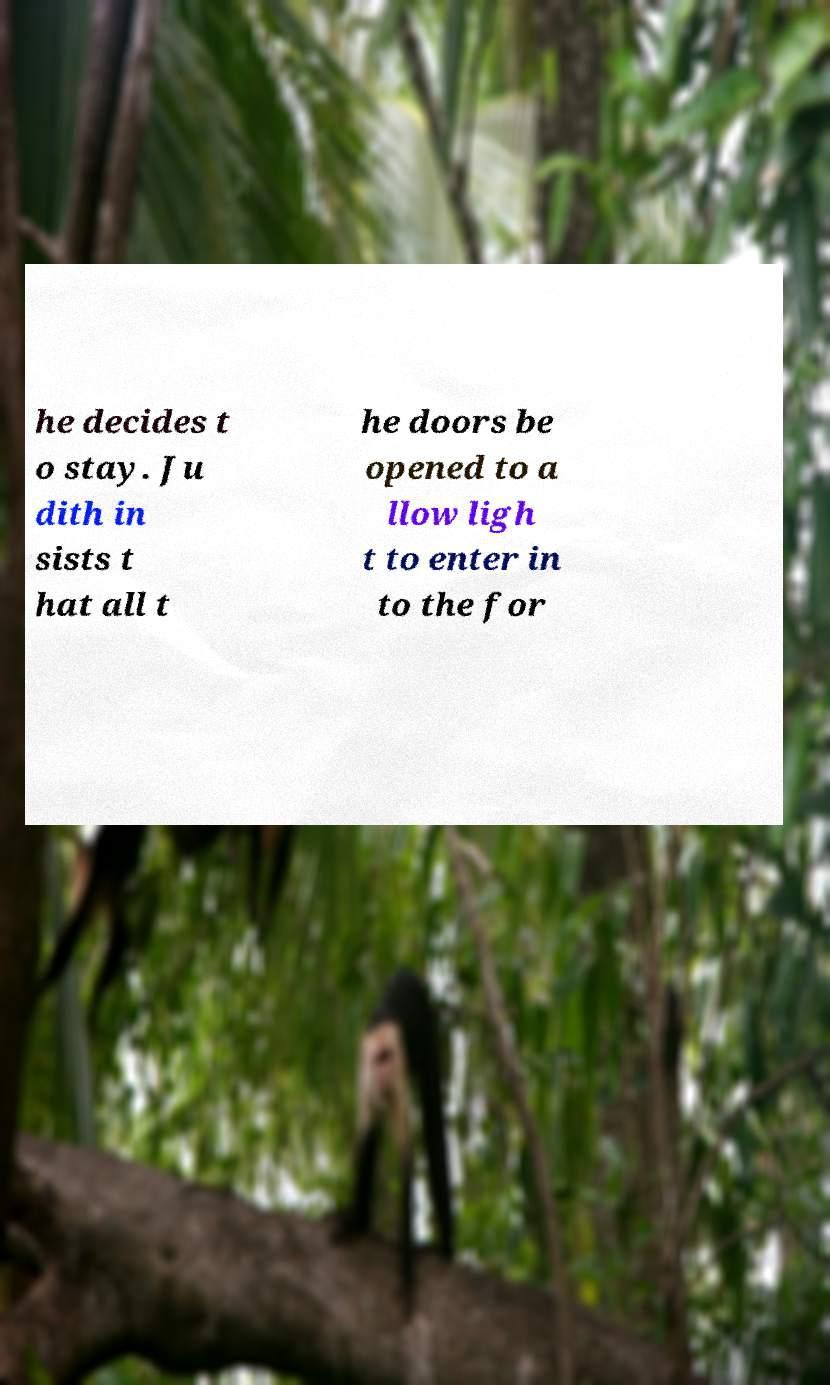Please read and relay the text visible in this image. What does it say? he decides t o stay. Ju dith in sists t hat all t he doors be opened to a llow ligh t to enter in to the for 